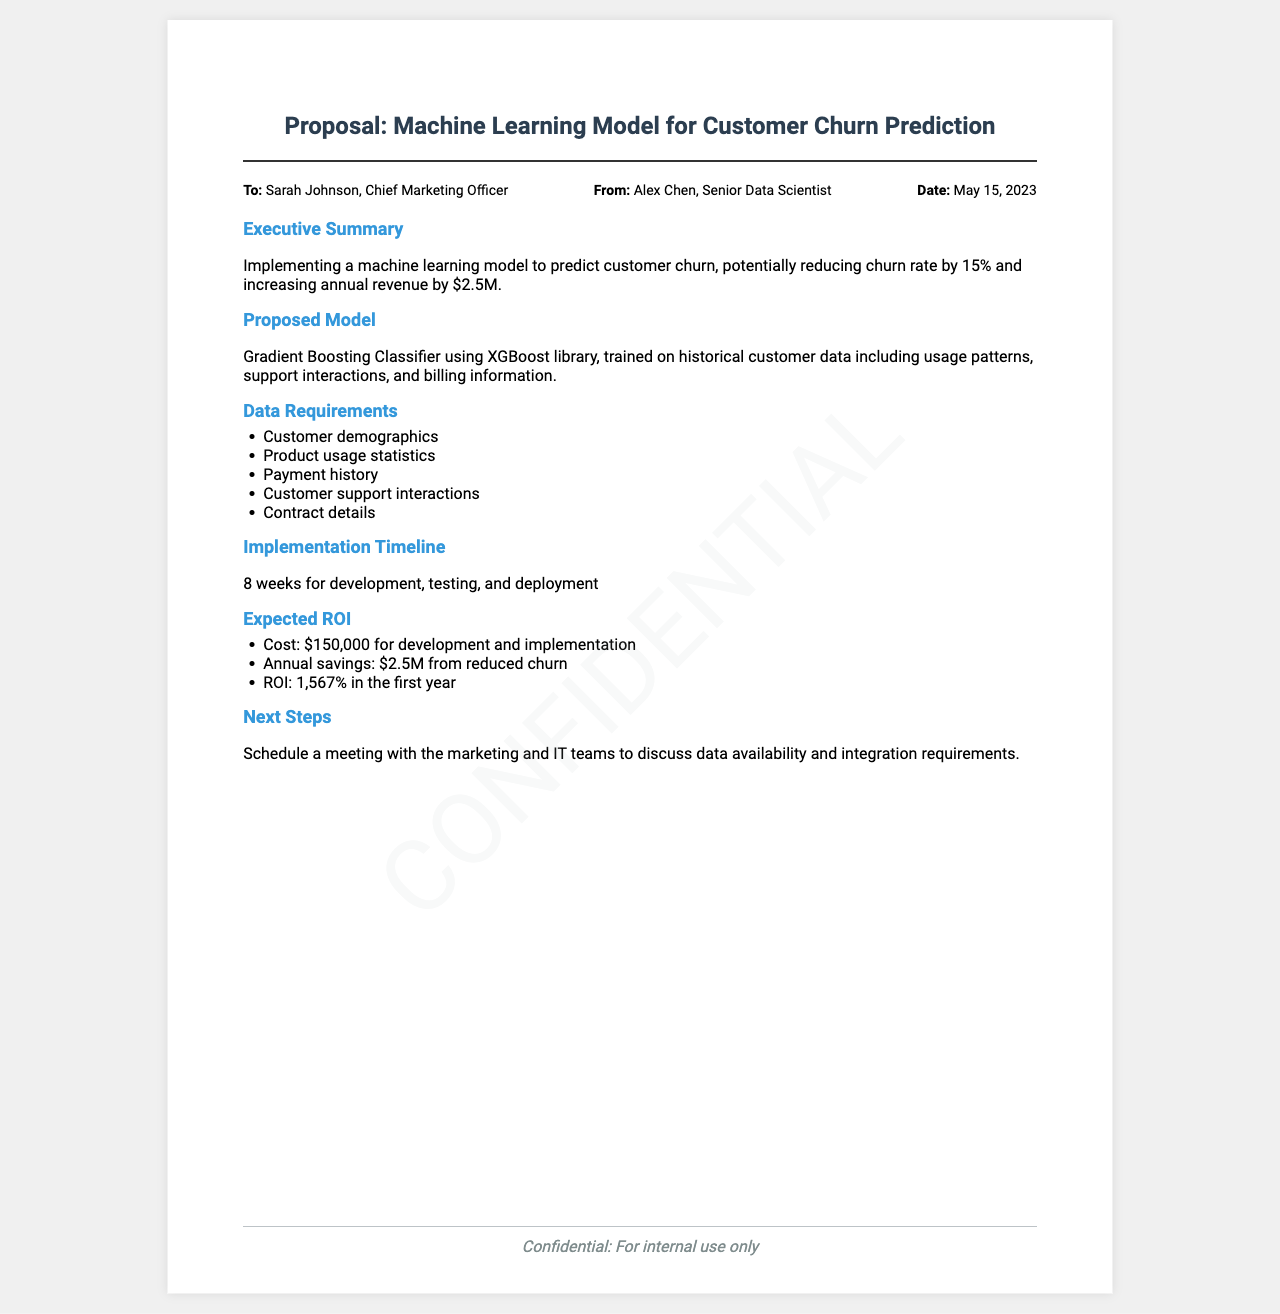What is the proposed model? The document specifies the proposed model as a Gradient Boosting Classifier using XGBoost library.
Answer: Gradient Boosting Classifier What is the expected ROI? The expected Return on Investment mentioned in the document is calculated based on the annual savings and cost of implementation.
Answer: 1,567% Who is the recipient of the fax? The document indicates that the fax is addressed to Sarah Johnson, the Chief Marketing Officer.
Answer: Sarah Johnson What is the implementation timeline? The document outlines that the timeline for development, testing, and deployment is 8 weeks.
Answer: 8 weeks What is the cost of development and implementation? The document states that the cost for development and implementation of the model is $150,000.
Answer: $150,000 What is the potential reduction in churn rate? The document mentions a potential reduction in the churn rate by 15%.
Answer: 15% What are the next steps proposed? The document suggests scheduling a meeting with the marketing and IT teams.
Answer: Schedule a meeting What type of data is required for the model? The document lists several types of data requirements including customer demographics and payment history.
Answer: Customer demographics, Product usage statistics, Payment history, Customer support interactions, Contract details When was the proposal sent? The document specifies the date the proposal was sent as May 15, 2023.
Answer: May 15, 2023 